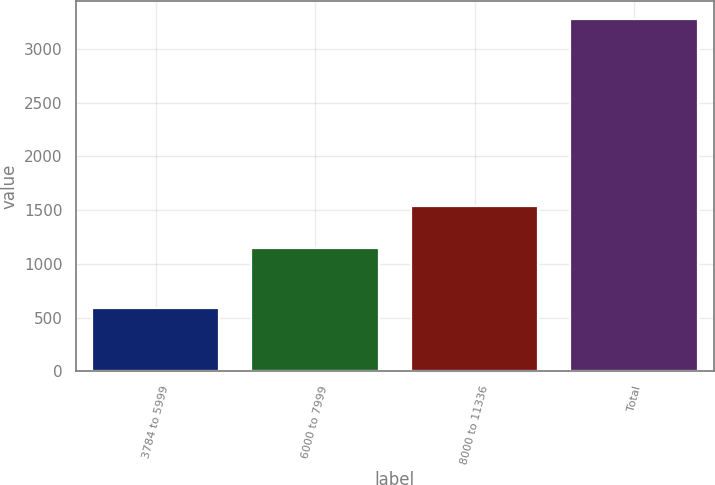Convert chart to OTSL. <chart><loc_0><loc_0><loc_500><loc_500><bar_chart><fcel>3784 to 5999<fcel>6000 to 7999<fcel>8000 to 11336<fcel>Total<nl><fcel>593<fcel>1151<fcel>1536<fcel>3280<nl></chart> 